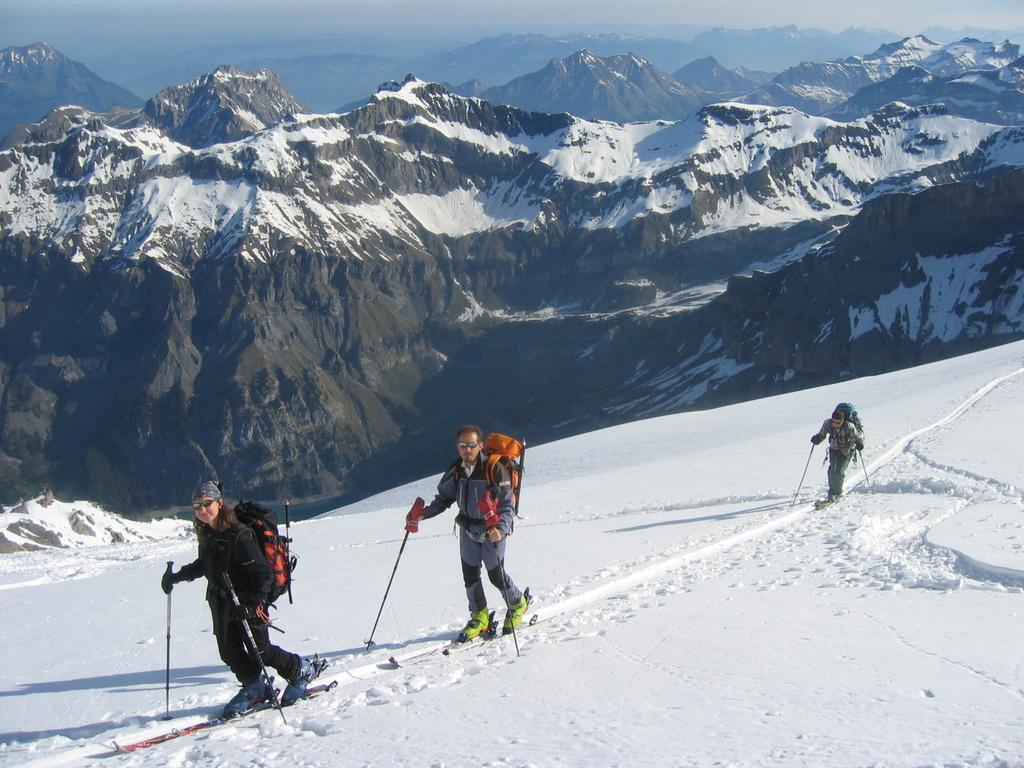How would you summarize this image in a sentence or two? This image consists of three persons skiing. They are wearing bags and ski-boards. At the bottom, there is snow. In the background, there are mountains covered with snow. 